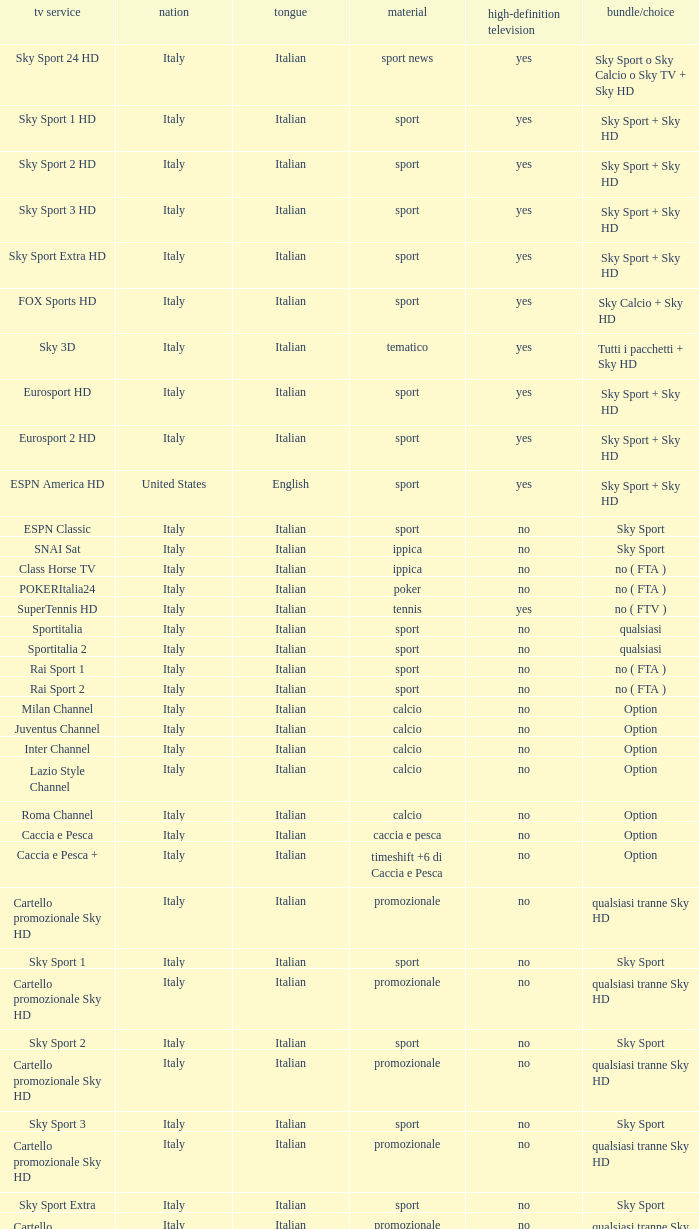What is Package/Option, when Content is Poker? No ( fta ). 